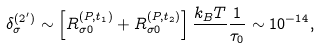Convert formula to latex. <formula><loc_0><loc_0><loc_500><loc_500>\delta ^ { ( 2 ^ { \prime } ) } _ { \sigma } \sim \left [ R _ { \sigma 0 } ^ { ( P , t _ { 1 } ) } + R _ { \sigma 0 } ^ { ( P , t _ { 2 } ) } \right ] \frac { k _ { B } T } { } \frac { 1 } { \tau _ { 0 } } \sim 1 0 ^ { - 1 4 } ,</formula> 